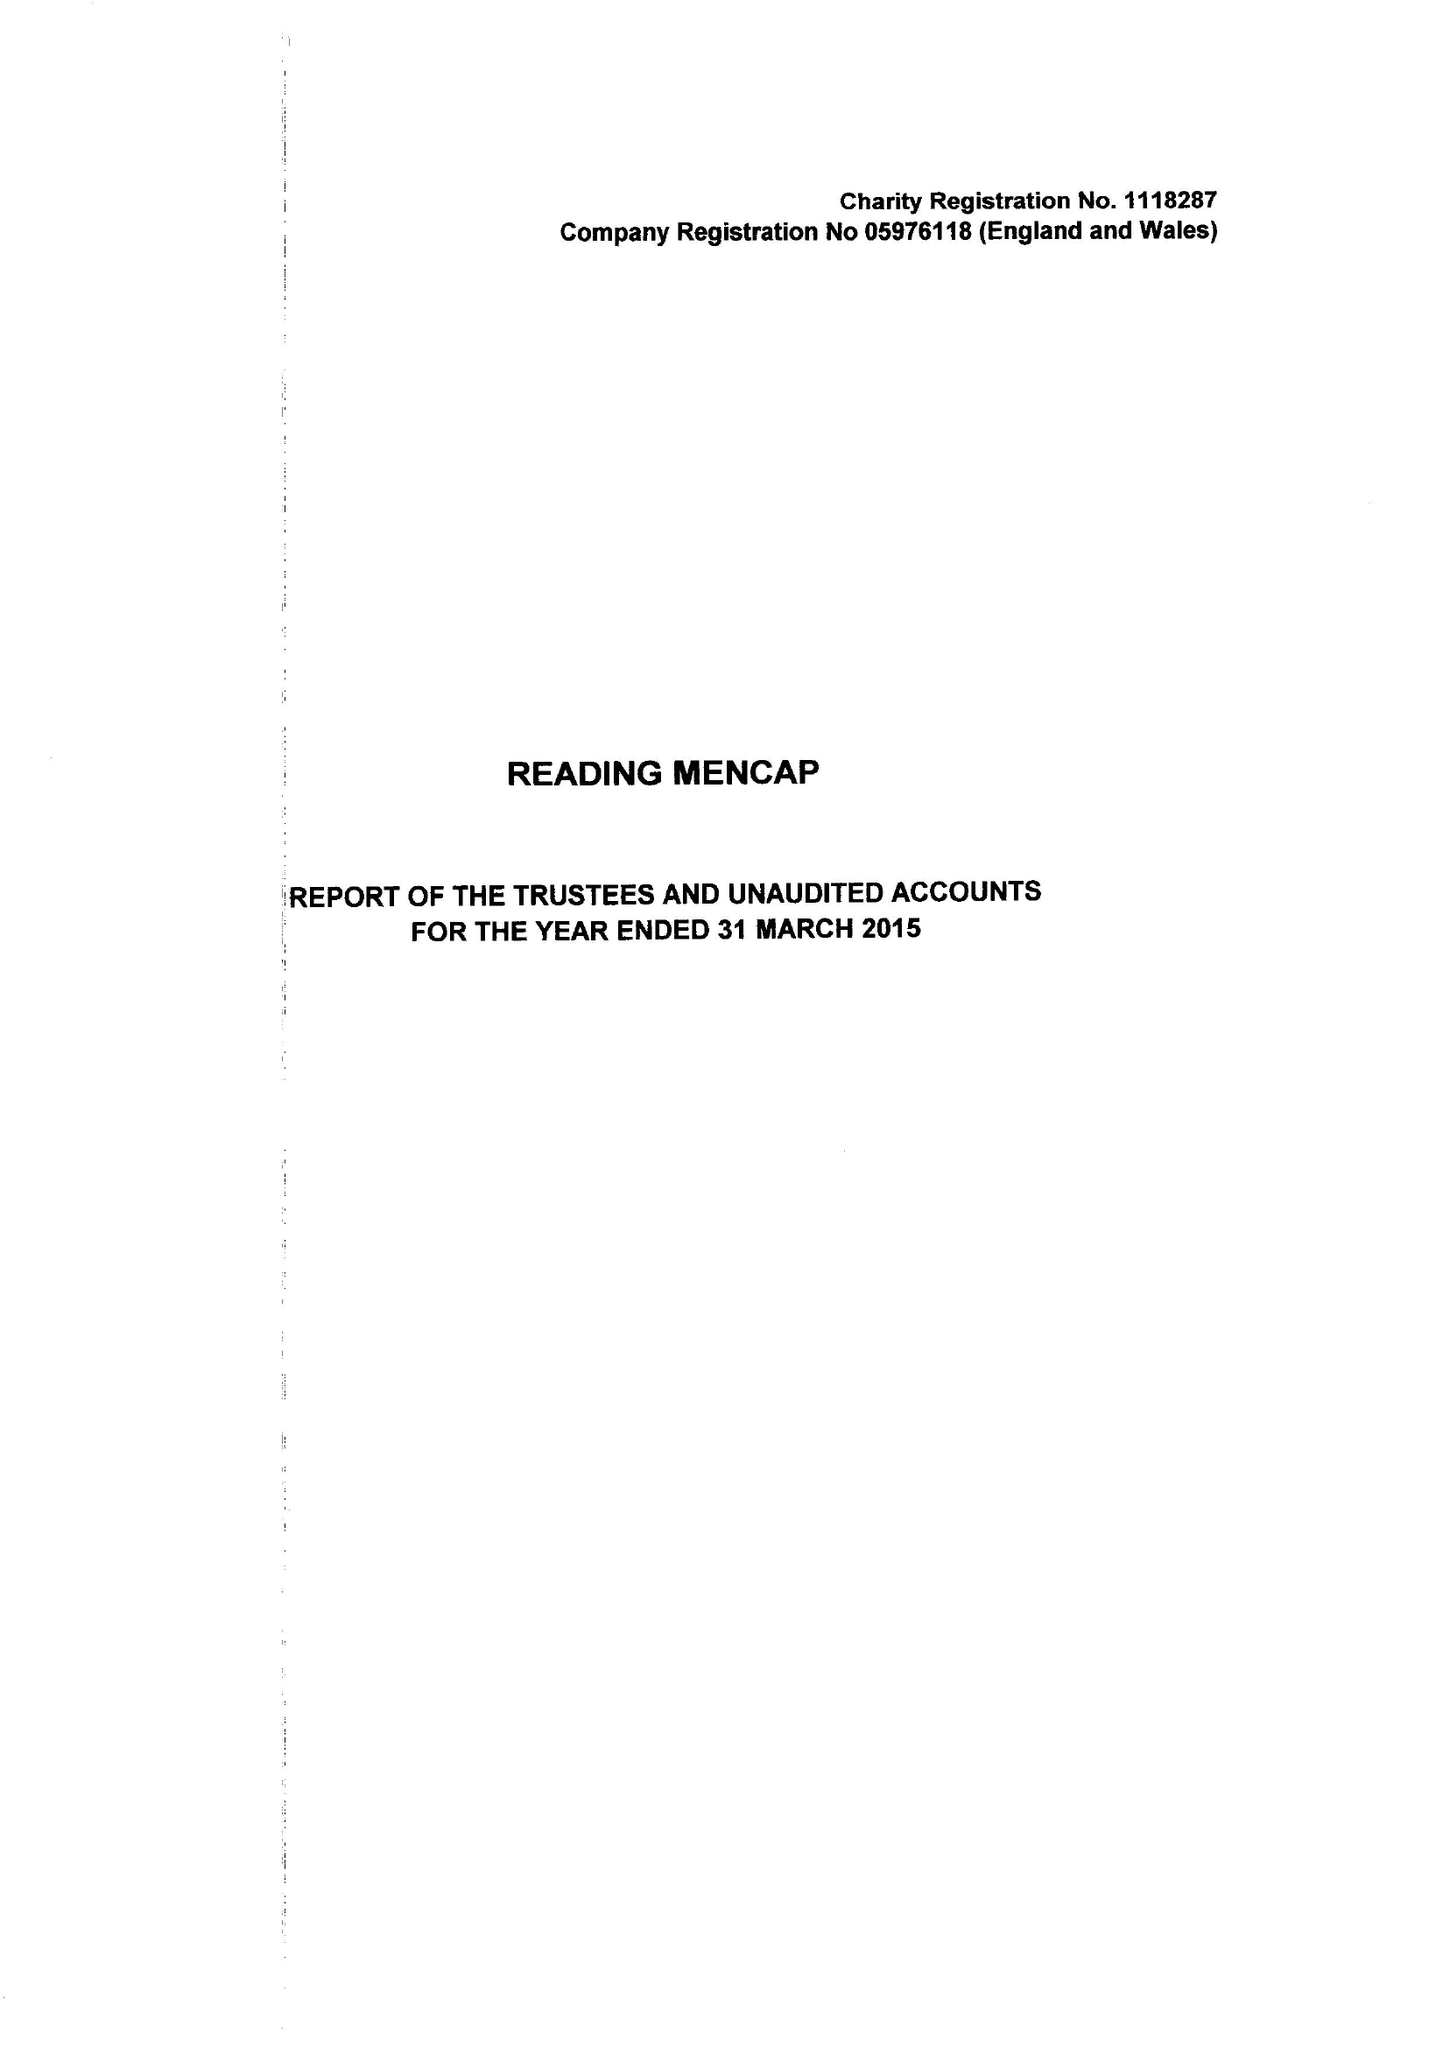What is the value for the address__street_line?
Answer the question using a single word or phrase. 21 ALEXANDRA ROAD 